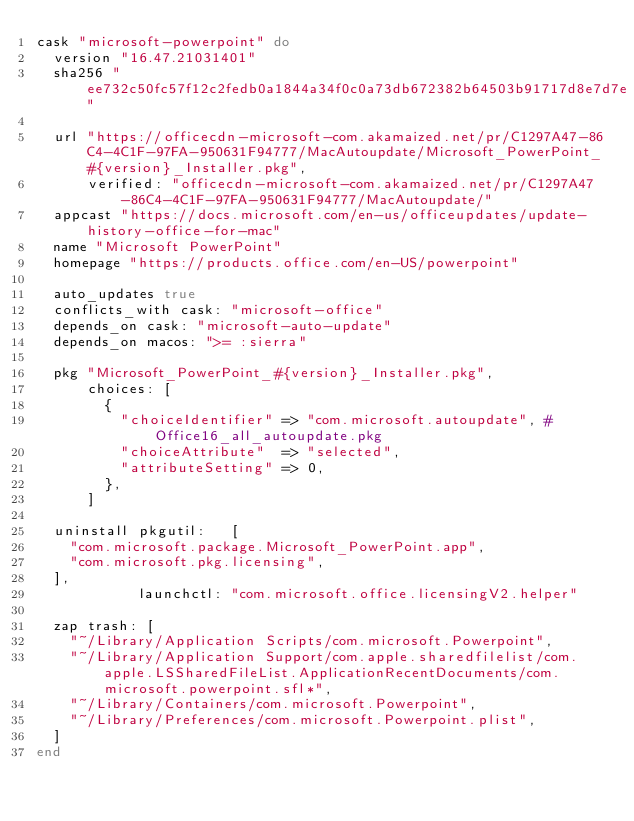<code> <loc_0><loc_0><loc_500><loc_500><_Ruby_>cask "microsoft-powerpoint" do
  version "16.47.21031401"
  sha256 "ee732c50fc57f12c2fedb0a1844a34f0c0a73db672382b64503b91717d8e7d7e"

  url "https://officecdn-microsoft-com.akamaized.net/pr/C1297A47-86C4-4C1F-97FA-950631F94777/MacAutoupdate/Microsoft_PowerPoint_#{version}_Installer.pkg",
      verified: "officecdn-microsoft-com.akamaized.net/pr/C1297A47-86C4-4C1F-97FA-950631F94777/MacAutoupdate/"
  appcast "https://docs.microsoft.com/en-us/officeupdates/update-history-office-for-mac"
  name "Microsoft PowerPoint"
  homepage "https://products.office.com/en-US/powerpoint"

  auto_updates true
  conflicts_with cask: "microsoft-office"
  depends_on cask: "microsoft-auto-update"
  depends_on macos: ">= :sierra"

  pkg "Microsoft_PowerPoint_#{version}_Installer.pkg",
      choices: [
        {
          "choiceIdentifier" => "com.microsoft.autoupdate", # Office16_all_autoupdate.pkg
          "choiceAttribute"  => "selected",
          "attributeSetting" => 0,
        },
      ]

  uninstall pkgutil:   [
    "com.microsoft.package.Microsoft_PowerPoint.app",
    "com.microsoft.pkg.licensing",
  ],
            launchctl: "com.microsoft.office.licensingV2.helper"

  zap trash: [
    "~/Library/Application Scripts/com.microsoft.Powerpoint",
    "~/Library/Application Support/com.apple.sharedfilelist/com.apple.LSSharedFileList.ApplicationRecentDocuments/com.microsoft.powerpoint.sfl*",
    "~/Library/Containers/com.microsoft.Powerpoint",
    "~/Library/Preferences/com.microsoft.Powerpoint.plist",
  ]
end
</code> 